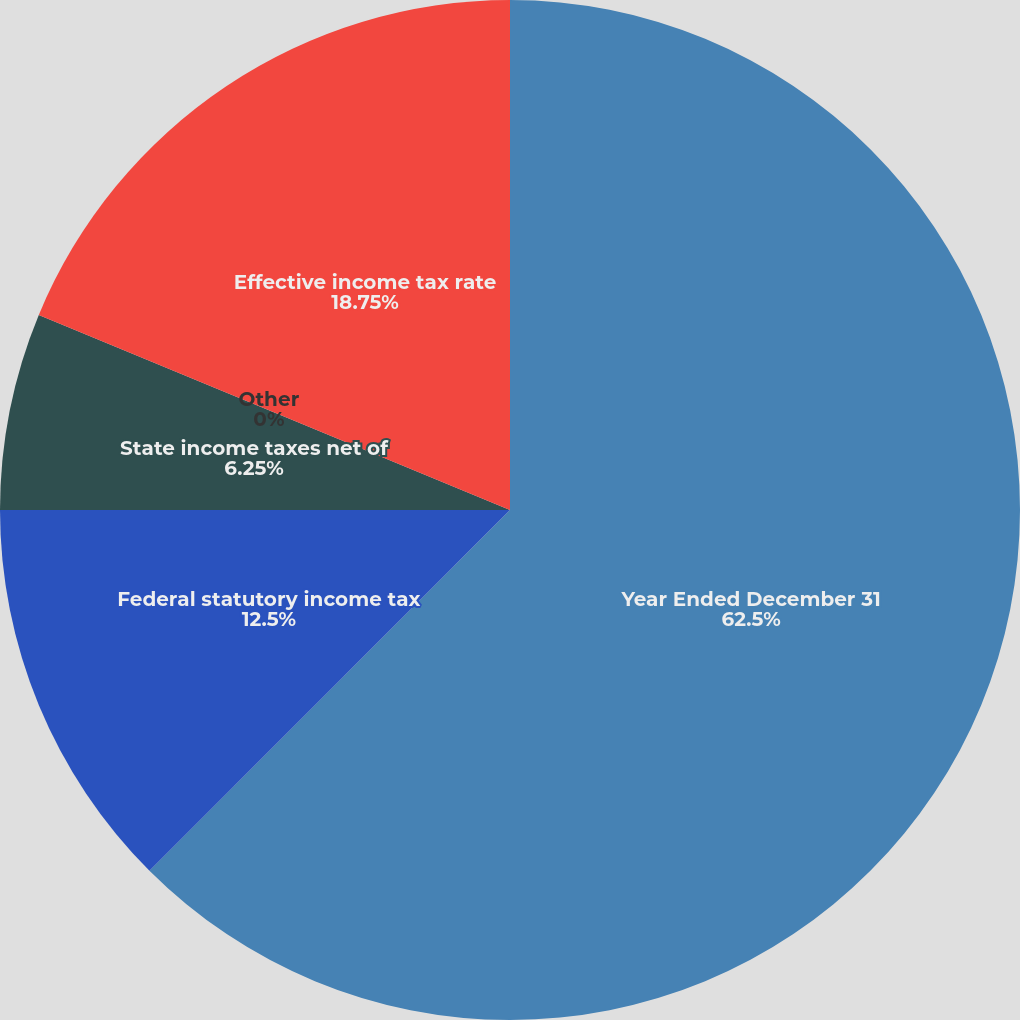Convert chart. <chart><loc_0><loc_0><loc_500><loc_500><pie_chart><fcel>Year Ended December 31<fcel>Federal statutory income tax<fcel>State income taxes net of<fcel>Other<fcel>Effective income tax rate<nl><fcel>62.49%<fcel>12.5%<fcel>6.25%<fcel>0.0%<fcel>18.75%<nl></chart> 